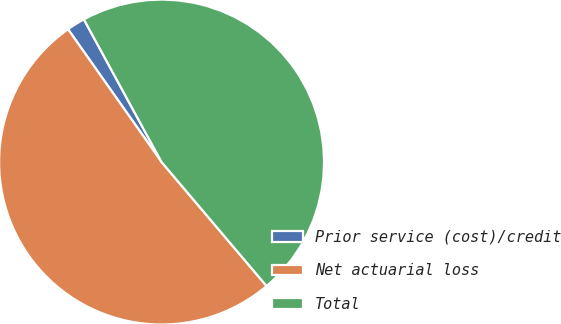Convert chart. <chart><loc_0><loc_0><loc_500><loc_500><pie_chart><fcel>Prior service (cost)/credit<fcel>Net actuarial loss<fcel>Total<nl><fcel>1.83%<fcel>51.42%<fcel>46.75%<nl></chart> 